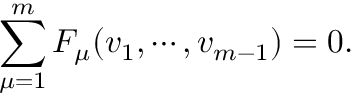Convert formula to latex. <formula><loc_0><loc_0><loc_500><loc_500>\sum _ { \mu = 1 } ^ { m } F _ { \mu } ( v _ { 1 } , \cdots , v _ { m - 1 } ) = 0 .</formula> 